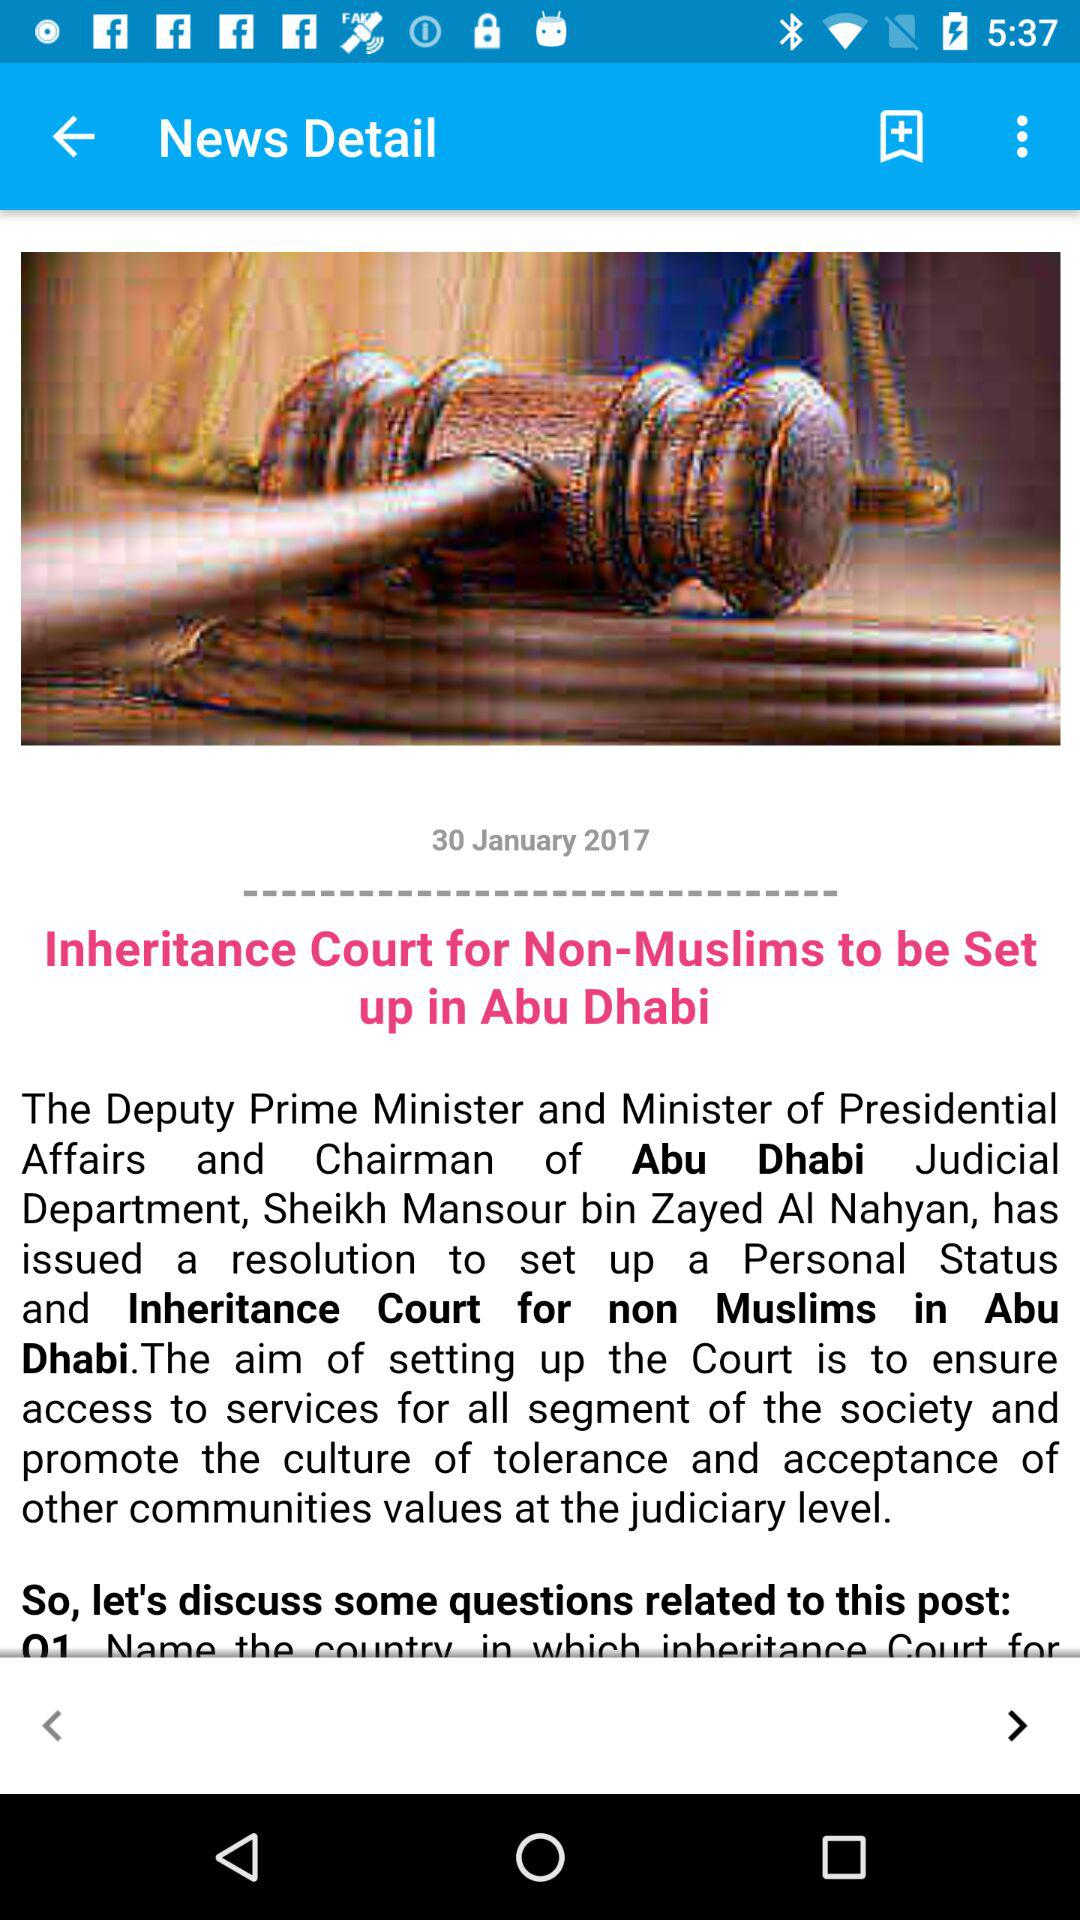When was the news published? The news was published on January 30, 2017. 